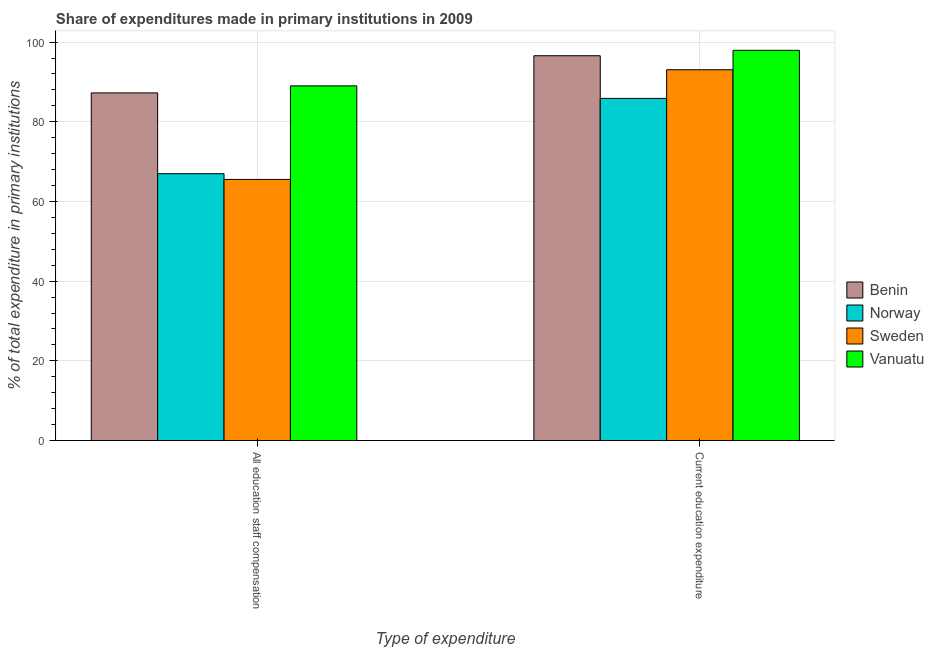Are the number of bars per tick equal to the number of legend labels?
Give a very brief answer. Yes. Are the number of bars on each tick of the X-axis equal?
Make the answer very short. Yes. How many bars are there on the 1st tick from the right?
Your answer should be very brief. 4. What is the label of the 2nd group of bars from the left?
Your answer should be compact. Current education expenditure. What is the expenditure in staff compensation in Sweden?
Offer a very short reply. 65.54. Across all countries, what is the maximum expenditure in staff compensation?
Make the answer very short. 89.01. Across all countries, what is the minimum expenditure in staff compensation?
Your answer should be compact. 65.54. In which country was the expenditure in education maximum?
Offer a very short reply. Vanuatu. In which country was the expenditure in staff compensation minimum?
Your answer should be very brief. Sweden. What is the total expenditure in education in the graph?
Your response must be concise. 373.44. What is the difference between the expenditure in staff compensation in Benin and that in Vanuatu?
Offer a terse response. -1.77. What is the difference between the expenditure in staff compensation in Sweden and the expenditure in education in Benin?
Keep it short and to the point. -31.04. What is the average expenditure in staff compensation per country?
Your answer should be very brief. 77.19. What is the difference between the expenditure in staff compensation and expenditure in education in Benin?
Your answer should be compact. -9.33. What is the ratio of the expenditure in education in Vanuatu to that in Sweden?
Offer a terse response. 1.05. Are all the bars in the graph horizontal?
Your response must be concise. No. How many countries are there in the graph?
Give a very brief answer. 4. What is the difference between two consecutive major ticks on the Y-axis?
Provide a succinct answer. 20. Does the graph contain any zero values?
Keep it short and to the point. No. How many legend labels are there?
Offer a terse response. 4. How are the legend labels stacked?
Offer a very short reply. Vertical. What is the title of the graph?
Your response must be concise. Share of expenditures made in primary institutions in 2009. Does "Central African Republic" appear as one of the legend labels in the graph?
Your answer should be very brief. No. What is the label or title of the X-axis?
Provide a short and direct response. Type of expenditure. What is the label or title of the Y-axis?
Provide a short and direct response. % of total expenditure in primary institutions. What is the % of total expenditure in primary institutions of Benin in All education staff compensation?
Your response must be concise. 87.25. What is the % of total expenditure in primary institutions in Norway in All education staff compensation?
Give a very brief answer. 66.97. What is the % of total expenditure in primary institutions of Sweden in All education staff compensation?
Provide a short and direct response. 65.54. What is the % of total expenditure in primary institutions in Vanuatu in All education staff compensation?
Keep it short and to the point. 89.01. What is the % of total expenditure in primary institutions in Benin in Current education expenditure?
Provide a short and direct response. 96.58. What is the % of total expenditure in primary institutions in Norway in Current education expenditure?
Make the answer very short. 85.87. What is the % of total expenditure in primary institutions in Sweden in Current education expenditure?
Provide a succinct answer. 93.06. What is the % of total expenditure in primary institutions of Vanuatu in Current education expenditure?
Your answer should be compact. 97.93. Across all Type of expenditure, what is the maximum % of total expenditure in primary institutions of Benin?
Your response must be concise. 96.58. Across all Type of expenditure, what is the maximum % of total expenditure in primary institutions of Norway?
Provide a short and direct response. 85.87. Across all Type of expenditure, what is the maximum % of total expenditure in primary institutions in Sweden?
Provide a short and direct response. 93.06. Across all Type of expenditure, what is the maximum % of total expenditure in primary institutions in Vanuatu?
Offer a terse response. 97.93. Across all Type of expenditure, what is the minimum % of total expenditure in primary institutions in Benin?
Offer a terse response. 87.25. Across all Type of expenditure, what is the minimum % of total expenditure in primary institutions of Norway?
Keep it short and to the point. 66.97. Across all Type of expenditure, what is the minimum % of total expenditure in primary institutions in Sweden?
Your answer should be very brief. 65.54. Across all Type of expenditure, what is the minimum % of total expenditure in primary institutions of Vanuatu?
Make the answer very short. 89.01. What is the total % of total expenditure in primary institutions of Benin in the graph?
Provide a succinct answer. 183.82. What is the total % of total expenditure in primary institutions in Norway in the graph?
Offer a terse response. 152.84. What is the total % of total expenditure in primary institutions in Sweden in the graph?
Your answer should be very brief. 158.6. What is the total % of total expenditure in primary institutions in Vanuatu in the graph?
Give a very brief answer. 186.94. What is the difference between the % of total expenditure in primary institutions in Benin in All education staff compensation and that in Current education expenditure?
Make the answer very short. -9.33. What is the difference between the % of total expenditure in primary institutions of Norway in All education staff compensation and that in Current education expenditure?
Keep it short and to the point. -18.9. What is the difference between the % of total expenditure in primary institutions in Sweden in All education staff compensation and that in Current education expenditure?
Make the answer very short. -27.52. What is the difference between the % of total expenditure in primary institutions in Vanuatu in All education staff compensation and that in Current education expenditure?
Offer a terse response. -8.92. What is the difference between the % of total expenditure in primary institutions in Benin in All education staff compensation and the % of total expenditure in primary institutions in Norway in Current education expenditure?
Give a very brief answer. 1.38. What is the difference between the % of total expenditure in primary institutions of Benin in All education staff compensation and the % of total expenditure in primary institutions of Sweden in Current education expenditure?
Your answer should be compact. -5.82. What is the difference between the % of total expenditure in primary institutions of Benin in All education staff compensation and the % of total expenditure in primary institutions of Vanuatu in Current education expenditure?
Offer a terse response. -10.68. What is the difference between the % of total expenditure in primary institutions in Norway in All education staff compensation and the % of total expenditure in primary institutions in Sweden in Current education expenditure?
Your answer should be compact. -26.09. What is the difference between the % of total expenditure in primary institutions in Norway in All education staff compensation and the % of total expenditure in primary institutions in Vanuatu in Current education expenditure?
Your answer should be very brief. -30.96. What is the difference between the % of total expenditure in primary institutions in Sweden in All education staff compensation and the % of total expenditure in primary institutions in Vanuatu in Current education expenditure?
Keep it short and to the point. -32.39. What is the average % of total expenditure in primary institutions in Benin per Type of expenditure?
Your answer should be very brief. 91.91. What is the average % of total expenditure in primary institutions of Norway per Type of expenditure?
Keep it short and to the point. 76.42. What is the average % of total expenditure in primary institutions in Sweden per Type of expenditure?
Ensure brevity in your answer.  79.3. What is the average % of total expenditure in primary institutions in Vanuatu per Type of expenditure?
Your answer should be very brief. 93.47. What is the difference between the % of total expenditure in primary institutions of Benin and % of total expenditure in primary institutions of Norway in All education staff compensation?
Make the answer very short. 20.27. What is the difference between the % of total expenditure in primary institutions in Benin and % of total expenditure in primary institutions in Sweden in All education staff compensation?
Give a very brief answer. 21.71. What is the difference between the % of total expenditure in primary institutions in Benin and % of total expenditure in primary institutions in Vanuatu in All education staff compensation?
Keep it short and to the point. -1.77. What is the difference between the % of total expenditure in primary institutions in Norway and % of total expenditure in primary institutions in Sweden in All education staff compensation?
Make the answer very short. 1.44. What is the difference between the % of total expenditure in primary institutions in Norway and % of total expenditure in primary institutions in Vanuatu in All education staff compensation?
Your answer should be very brief. -22.04. What is the difference between the % of total expenditure in primary institutions in Sweden and % of total expenditure in primary institutions in Vanuatu in All education staff compensation?
Provide a succinct answer. -23.47. What is the difference between the % of total expenditure in primary institutions in Benin and % of total expenditure in primary institutions in Norway in Current education expenditure?
Your answer should be very brief. 10.71. What is the difference between the % of total expenditure in primary institutions of Benin and % of total expenditure in primary institutions of Sweden in Current education expenditure?
Ensure brevity in your answer.  3.52. What is the difference between the % of total expenditure in primary institutions of Benin and % of total expenditure in primary institutions of Vanuatu in Current education expenditure?
Ensure brevity in your answer.  -1.35. What is the difference between the % of total expenditure in primary institutions of Norway and % of total expenditure in primary institutions of Sweden in Current education expenditure?
Your answer should be very brief. -7.19. What is the difference between the % of total expenditure in primary institutions in Norway and % of total expenditure in primary institutions in Vanuatu in Current education expenditure?
Your answer should be compact. -12.06. What is the difference between the % of total expenditure in primary institutions in Sweden and % of total expenditure in primary institutions in Vanuatu in Current education expenditure?
Your response must be concise. -4.87. What is the ratio of the % of total expenditure in primary institutions of Benin in All education staff compensation to that in Current education expenditure?
Give a very brief answer. 0.9. What is the ratio of the % of total expenditure in primary institutions in Norway in All education staff compensation to that in Current education expenditure?
Provide a succinct answer. 0.78. What is the ratio of the % of total expenditure in primary institutions of Sweden in All education staff compensation to that in Current education expenditure?
Make the answer very short. 0.7. What is the ratio of the % of total expenditure in primary institutions of Vanuatu in All education staff compensation to that in Current education expenditure?
Ensure brevity in your answer.  0.91. What is the difference between the highest and the second highest % of total expenditure in primary institutions in Benin?
Make the answer very short. 9.33. What is the difference between the highest and the second highest % of total expenditure in primary institutions of Norway?
Your answer should be very brief. 18.9. What is the difference between the highest and the second highest % of total expenditure in primary institutions of Sweden?
Give a very brief answer. 27.52. What is the difference between the highest and the second highest % of total expenditure in primary institutions of Vanuatu?
Give a very brief answer. 8.92. What is the difference between the highest and the lowest % of total expenditure in primary institutions of Benin?
Your answer should be compact. 9.33. What is the difference between the highest and the lowest % of total expenditure in primary institutions in Norway?
Your answer should be very brief. 18.9. What is the difference between the highest and the lowest % of total expenditure in primary institutions in Sweden?
Ensure brevity in your answer.  27.52. What is the difference between the highest and the lowest % of total expenditure in primary institutions of Vanuatu?
Ensure brevity in your answer.  8.92. 